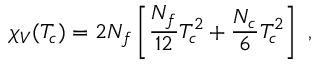Convert formula to latex. <formula><loc_0><loc_0><loc_500><loc_500>\chi _ { V } ( T _ { c } ) = 2 N _ { f } \left [ \frac { N _ { f } } { 1 2 } T _ { c } ^ { 2 } + \frac { N _ { c } } { 6 } T _ { c } ^ { 2 } \right ] \ ,</formula> 